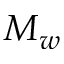Convert formula to latex. <formula><loc_0><loc_0><loc_500><loc_500>M _ { w }</formula> 